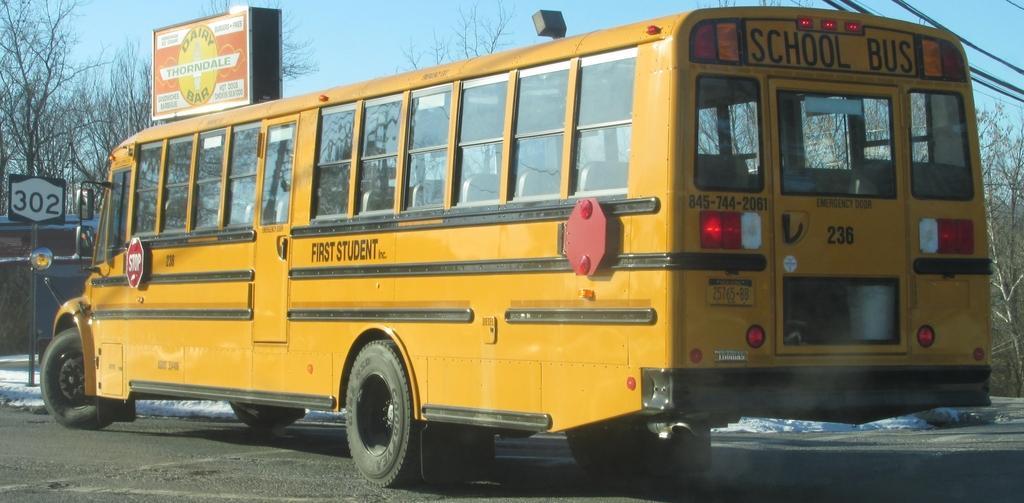Can you describe this image briefly? In the foreground I can see a bus and a board on the road. In the background I can see trees, poles and the sky. This image is taken may be during a day. 